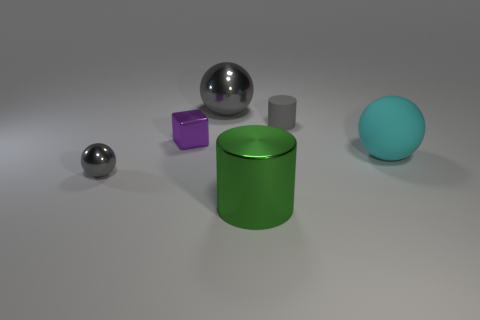Do the metallic object behind the purple object and the rubber thing in front of the small gray rubber object have the same shape?
Your response must be concise. Yes. What is the size of the gray shiny sphere that is in front of the cylinder that is behind the rubber sphere that is on the right side of the tiny cube?
Your answer should be very brief. Small. There is a sphere that is behind the big cyan thing; what is its size?
Keep it short and to the point. Large. There is a cylinder to the left of the tiny gray cylinder; what is its material?
Keep it short and to the point. Metal. How many gray objects are either matte blocks or cylinders?
Provide a short and direct response. 1. Is the cyan sphere made of the same material as the big thing that is left of the big cylinder?
Your answer should be compact. No. Are there an equal number of big rubber spheres that are behind the large gray metallic object and big metal cylinders that are on the left side of the small purple metallic thing?
Make the answer very short. Yes. There is a purple shiny object; is it the same size as the gray ball behind the small gray matte cylinder?
Provide a short and direct response. No. Is the number of cyan balls on the left side of the purple object greater than the number of big cyan matte balls?
Offer a terse response. No. What number of shiny cylinders have the same size as the cyan matte thing?
Provide a succinct answer. 1. 